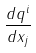Convert formula to latex. <formula><loc_0><loc_0><loc_500><loc_500>\frac { d q ^ { i } } { d x _ { j } }</formula> 